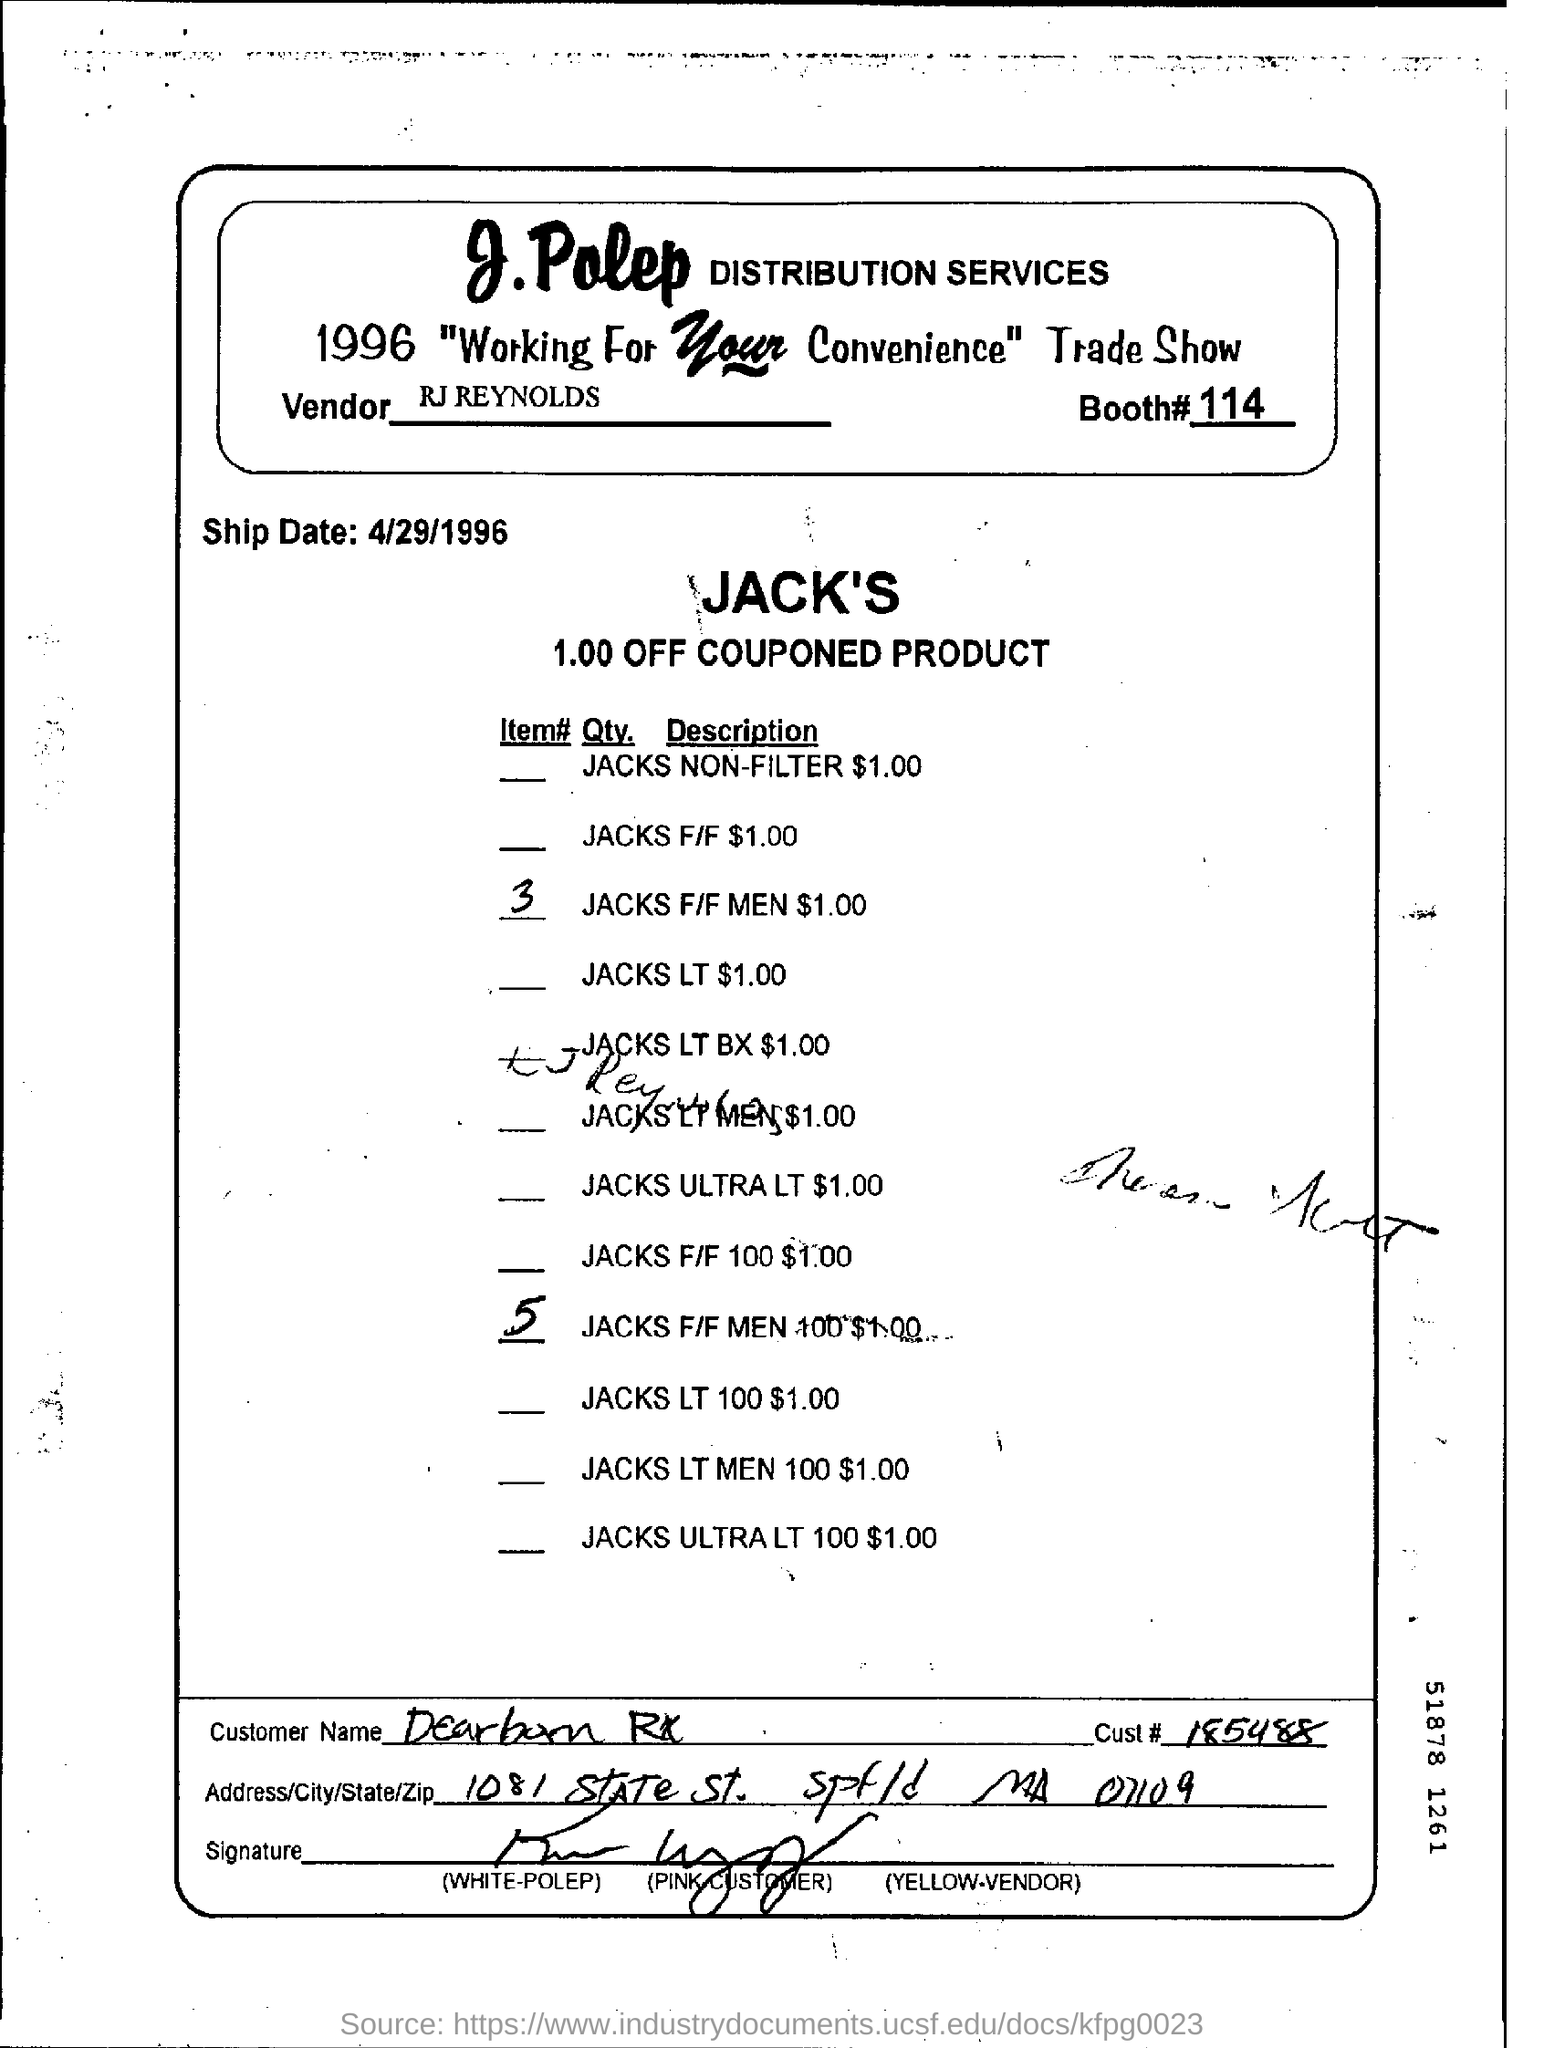Point out several critical features in this image. The number is 185488. The booth number is #114. The vendor is RJ Reynolds. The ship date is April 29th, 1996. 